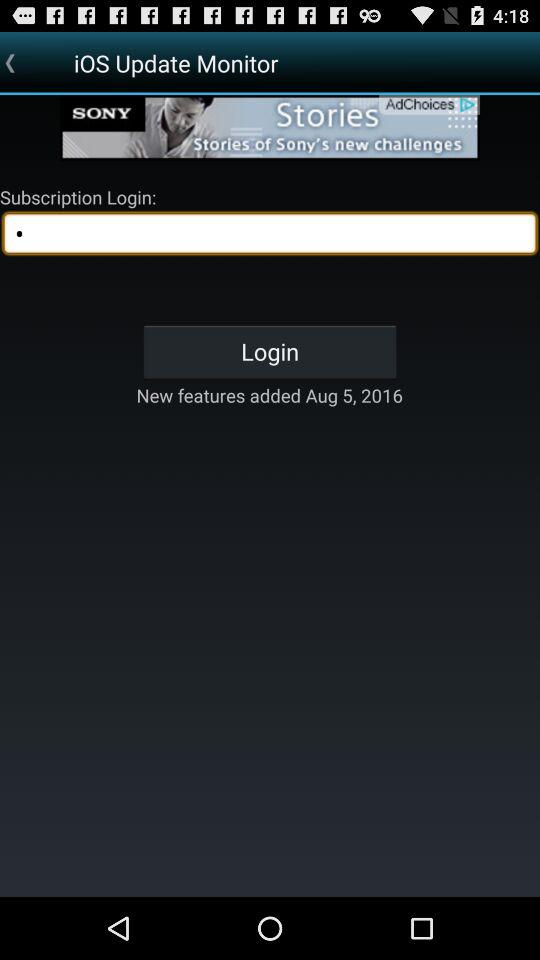On what date were the new features added? The new features were added on August 5, 2016. 